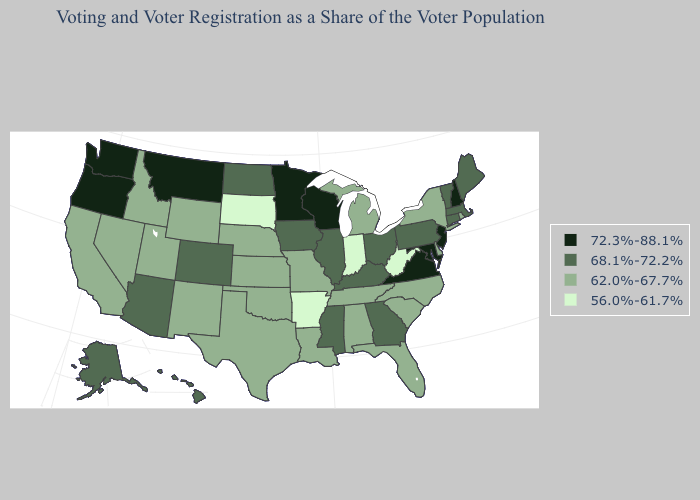Name the states that have a value in the range 62.0%-67.7%?
Give a very brief answer. Alabama, California, Delaware, Florida, Idaho, Kansas, Louisiana, Michigan, Missouri, Nebraska, Nevada, New Mexico, New York, North Carolina, Oklahoma, Rhode Island, South Carolina, Tennessee, Texas, Utah, Wyoming. What is the highest value in the USA?
Be succinct. 72.3%-88.1%. Does South Dakota have the lowest value in the USA?
Keep it brief. Yes. Among the states that border Oregon , does Washington have the lowest value?
Quick response, please. No. Name the states that have a value in the range 62.0%-67.7%?
Keep it brief. Alabama, California, Delaware, Florida, Idaho, Kansas, Louisiana, Michigan, Missouri, Nebraska, Nevada, New Mexico, New York, North Carolina, Oklahoma, Rhode Island, South Carolina, Tennessee, Texas, Utah, Wyoming. Among the states that border South Carolina , which have the lowest value?
Answer briefly. North Carolina. What is the value of New Mexico?
Write a very short answer. 62.0%-67.7%. What is the lowest value in the MidWest?
Be succinct. 56.0%-61.7%. What is the highest value in states that border North Carolina?
Give a very brief answer. 72.3%-88.1%. Name the states that have a value in the range 68.1%-72.2%?
Answer briefly. Alaska, Arizona, Colorado, Connecticut, Georgia, Hawaii, Illinois, Iowa, Kentucky, Maine, Massachusetts, Mississippi, North Dakota, Ohio, Pennsylvania, Vermont. Does Arkansas have the lowest value in the South?
Write a very short answer. Yes. Does Illinois have the lowest value in the USA?
Short answer required. No. Which states have the lowest value in the USA?
Be succinct. Arkansas, Indiana, South Dakota, West Virginia. Is the legend a continuous bar?
Be succinct. No. How many symbols are there in the legend?
Answer briefly. 4. 